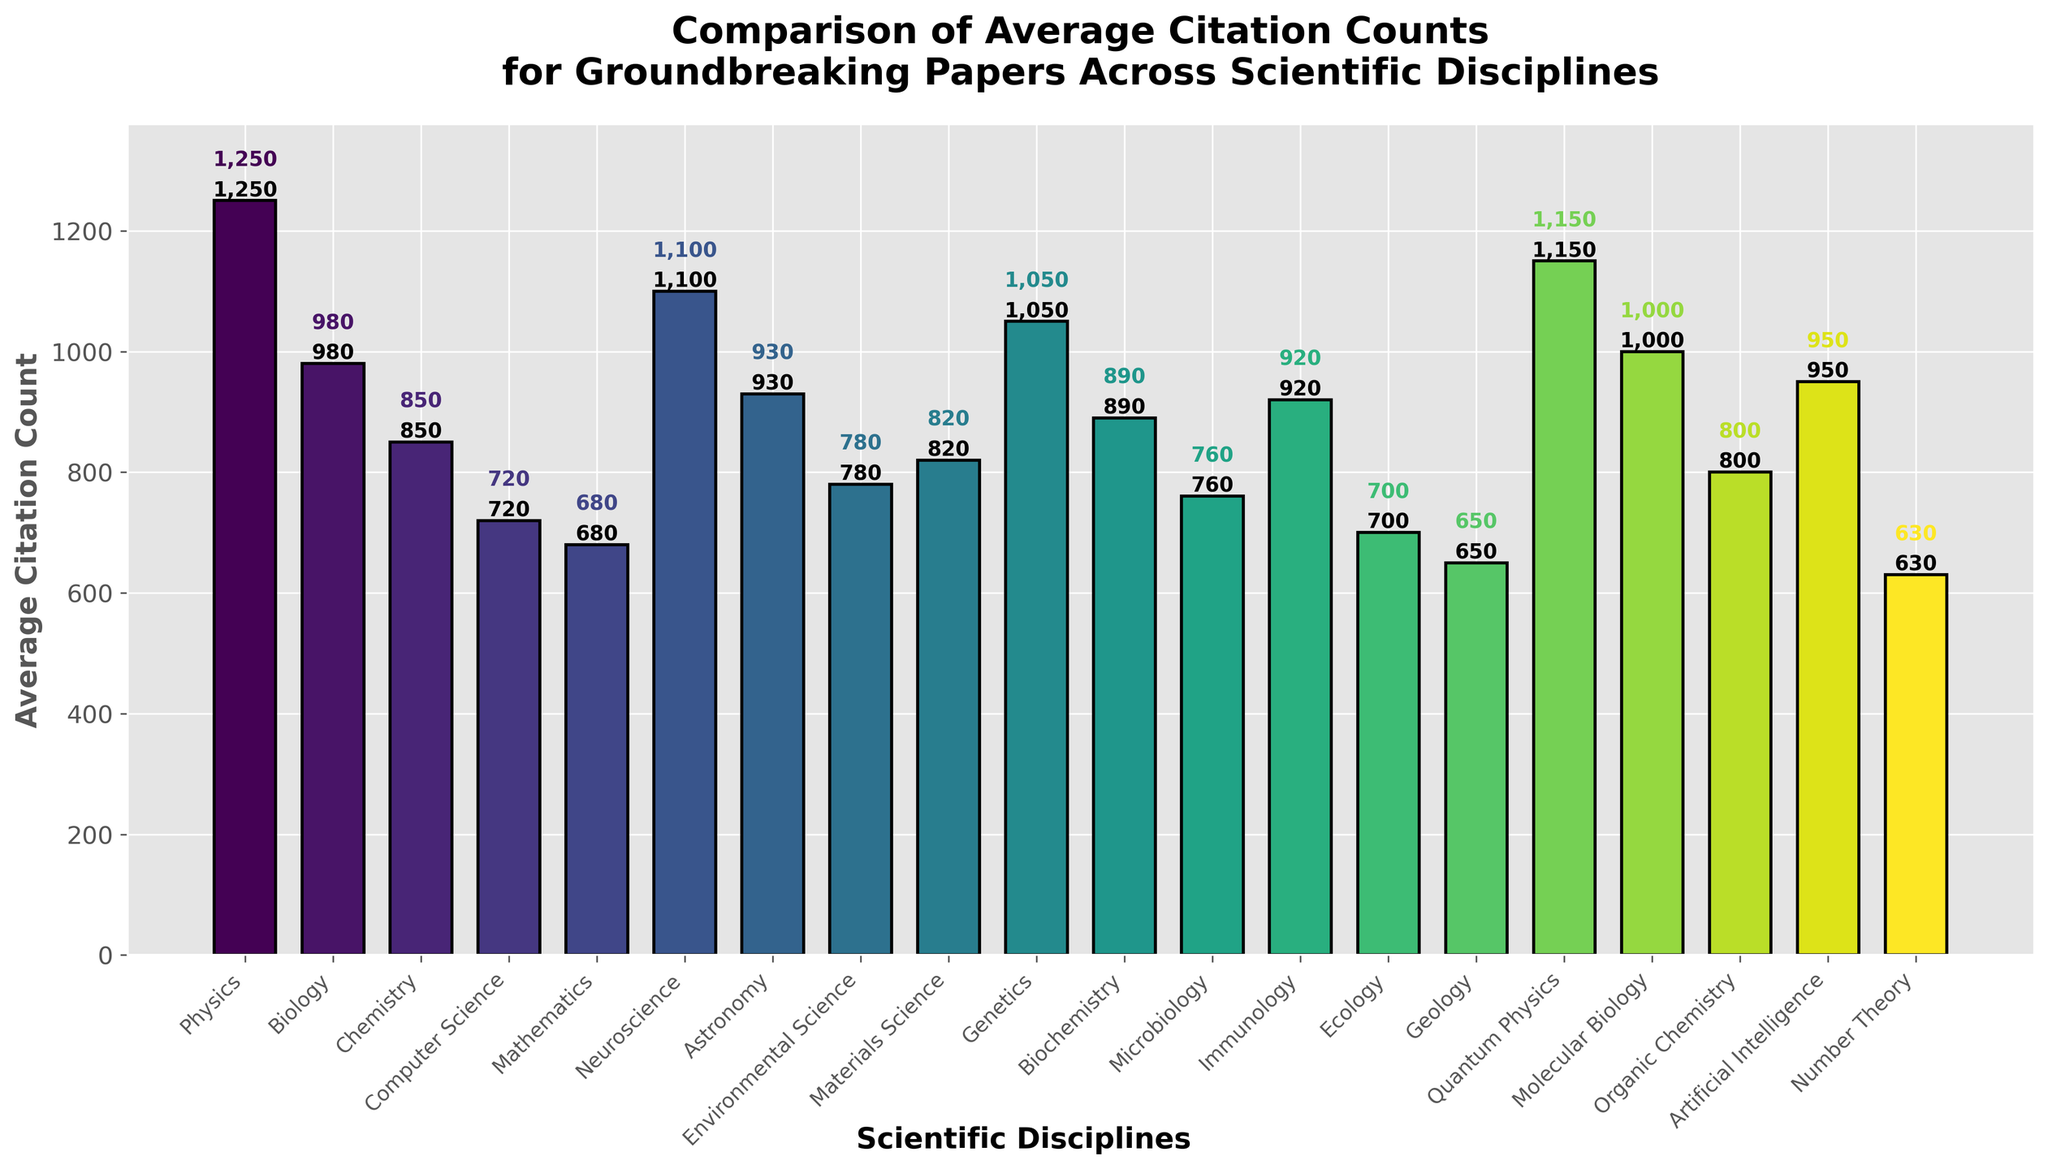Which discipline has the highest average citation count? The bar for Physics is the tallest, indicating it has the highest average citation count among the disciplines.
Answer: Physics What is the difference in average citation counts between Physics and Computer Science? The bar for Physics has a height of 1250, and the bar for Computer Science has a height of 720. The difference is calculated as 1250 - 720.
Answer: 530 How does the average citation count for Genetics compare to that of Neuroscience? The bar for Genetics has a height of 1050, while the bar for Neuroscience has a height of 1100. Neuroscience has a slightly higher average citation count than Genetics.
Answer: Neuroscience is higher What is the combined average citation count of Chemistry, Biology, and Biochemistry? The heights of the bars are Chemistry (850), Biology (980), and Biochemistry (890). Sum these values: 850 + 980 + 890.
Answer: 2720 Which disciplines have average citation counts lower than 800? By observing the bars: Mathematics (680), Ecology (700), and Geology (650) all have heights less than 800.
Answer: Mathematics, Ecology, Geology What is the average value of the top three disciplines by citation count? The top three are Physics (1250), Quantum Physics (1150), and Neuroscience (1100). Calculate the average: (1250 + 1150 + 1100) / 3.
Answer: 1167 Which disciplines fall within the range of 800 to 1000 average citation counts? By observing the bars, these disciplines show heights in that range: Chemistry (850), Astronomy (930), Organic Chemistry (800), Artificial Intelligence (950), and Molecular Biology (1000).
Answer: Chemistry, Astronomy, Organic Chemistry, Artificial Intelligence, Molecular Biology Which discipline is represented by a bar with height closest to 700? The bar closest to a height of 700 is Ecology with a height of 700.
Answer: Ecology What is the sum of the average citation counts for Environmental Science, Materials Science, and Immunology? The respective heights are: Environmental Science (780), Materials Science (820), and Immunology (920). Sum these values: 780 + 820 + 920.
Answer: 2520 Compare the heights of the bars for Computer Science and Artificial Intelligence. Which one is taller? The height of the bar for Artificial Intelligence (950) is taller than that for Computer Science (720).
Answer: Artificial Intelligence 